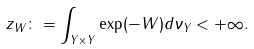Convert formula to latex. <formula><loc_0><loc_0><loc_500><loc_500>z _ { W } \colon = \int _ { Y \times Y } \exp ( - W ) d \nu _ { Y } < + \infty .</formula> 